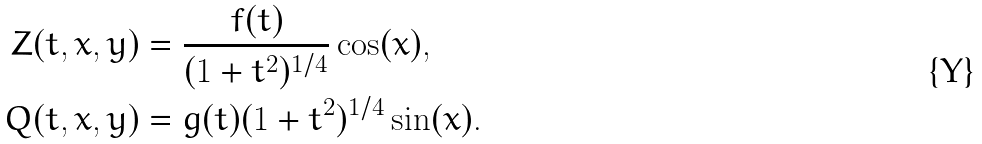<formula> <loc_0><loc_0><loc_500><loc_500>Z ( t , x , y ) & = \frac { f ( t ) } { ( 1 + t ^ { 2 } ) ^ { 1 / 4 } } \cos ( x ) , \\ Q ( t , x , y ) & = g ( t ) ( 1 + t ^ { 2 } ) ^ { 1 / 4 } \sin ( x ) .</formula> 